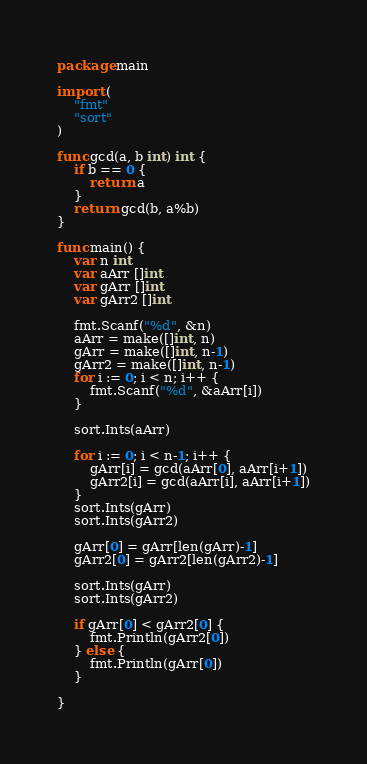Convert code to text. <code><loc_0><loc_0><loc_500><loc_500><_Go_>package main

import (
	"fmt"
	"sort"
)

func gcd(a, b int) int {
	if b == 0 {
		return a
	}
	return gcd(b, a%b)
}

func main() {
	var n int
	var aArr []int
	var gArr []int
	var gArr2 []int

	fmt.Scanf("%d", &n)
	aArr = make([]int, n)
	gArr = make([]int, n-1)
	gArr2 = make([]int, n-1)
	for i := 0; i < n; i++ {
		fmt.Scanf("%d", &aArr[i])
	}

	sort.Ints(aArr)

	for i := 0; i < n-1; i++ {
		gArr[i] = gcd(aArr[0], aArr[i+1])
		gArr2[i] = gcd(aArr[i], aArr[i+1])
	}
	sort.Ints(gArr)
	sort.Ints(gArr2)

	gArr[0] = gArr[len(gArr)-1]
	gArr2[0] = gArr2[len(gArr2)-1]

	sort.Ints(gArr)
	sort.Ints(gArr2)

	if gArr[0] < gArr2[0] {
		fmt.Println(gArr2[0])
	} else {
		fmt.Println(gArr[0])
	}

}
</code> 